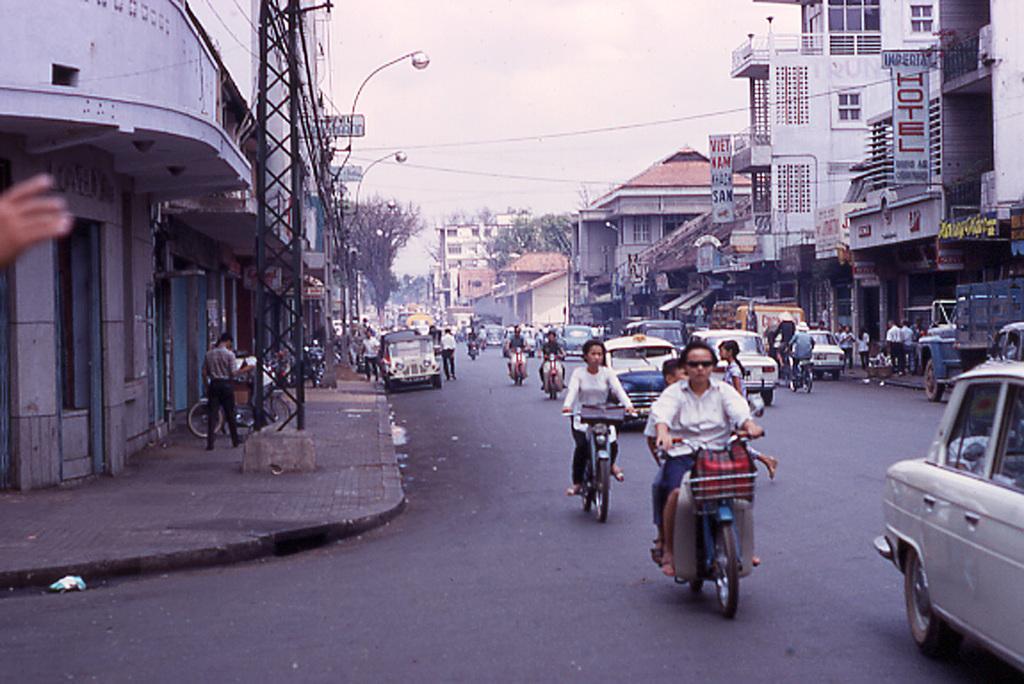In one or two sentences, can you explain what this image depicts? In this image on the right side and left side there are houses, trees and buildings. And in the center there is a roads, on the road there are some vehicles and some persons are sitting on vehicles and driving. And some people are walking on footpath and there are some towers, wires, poles and lights. 